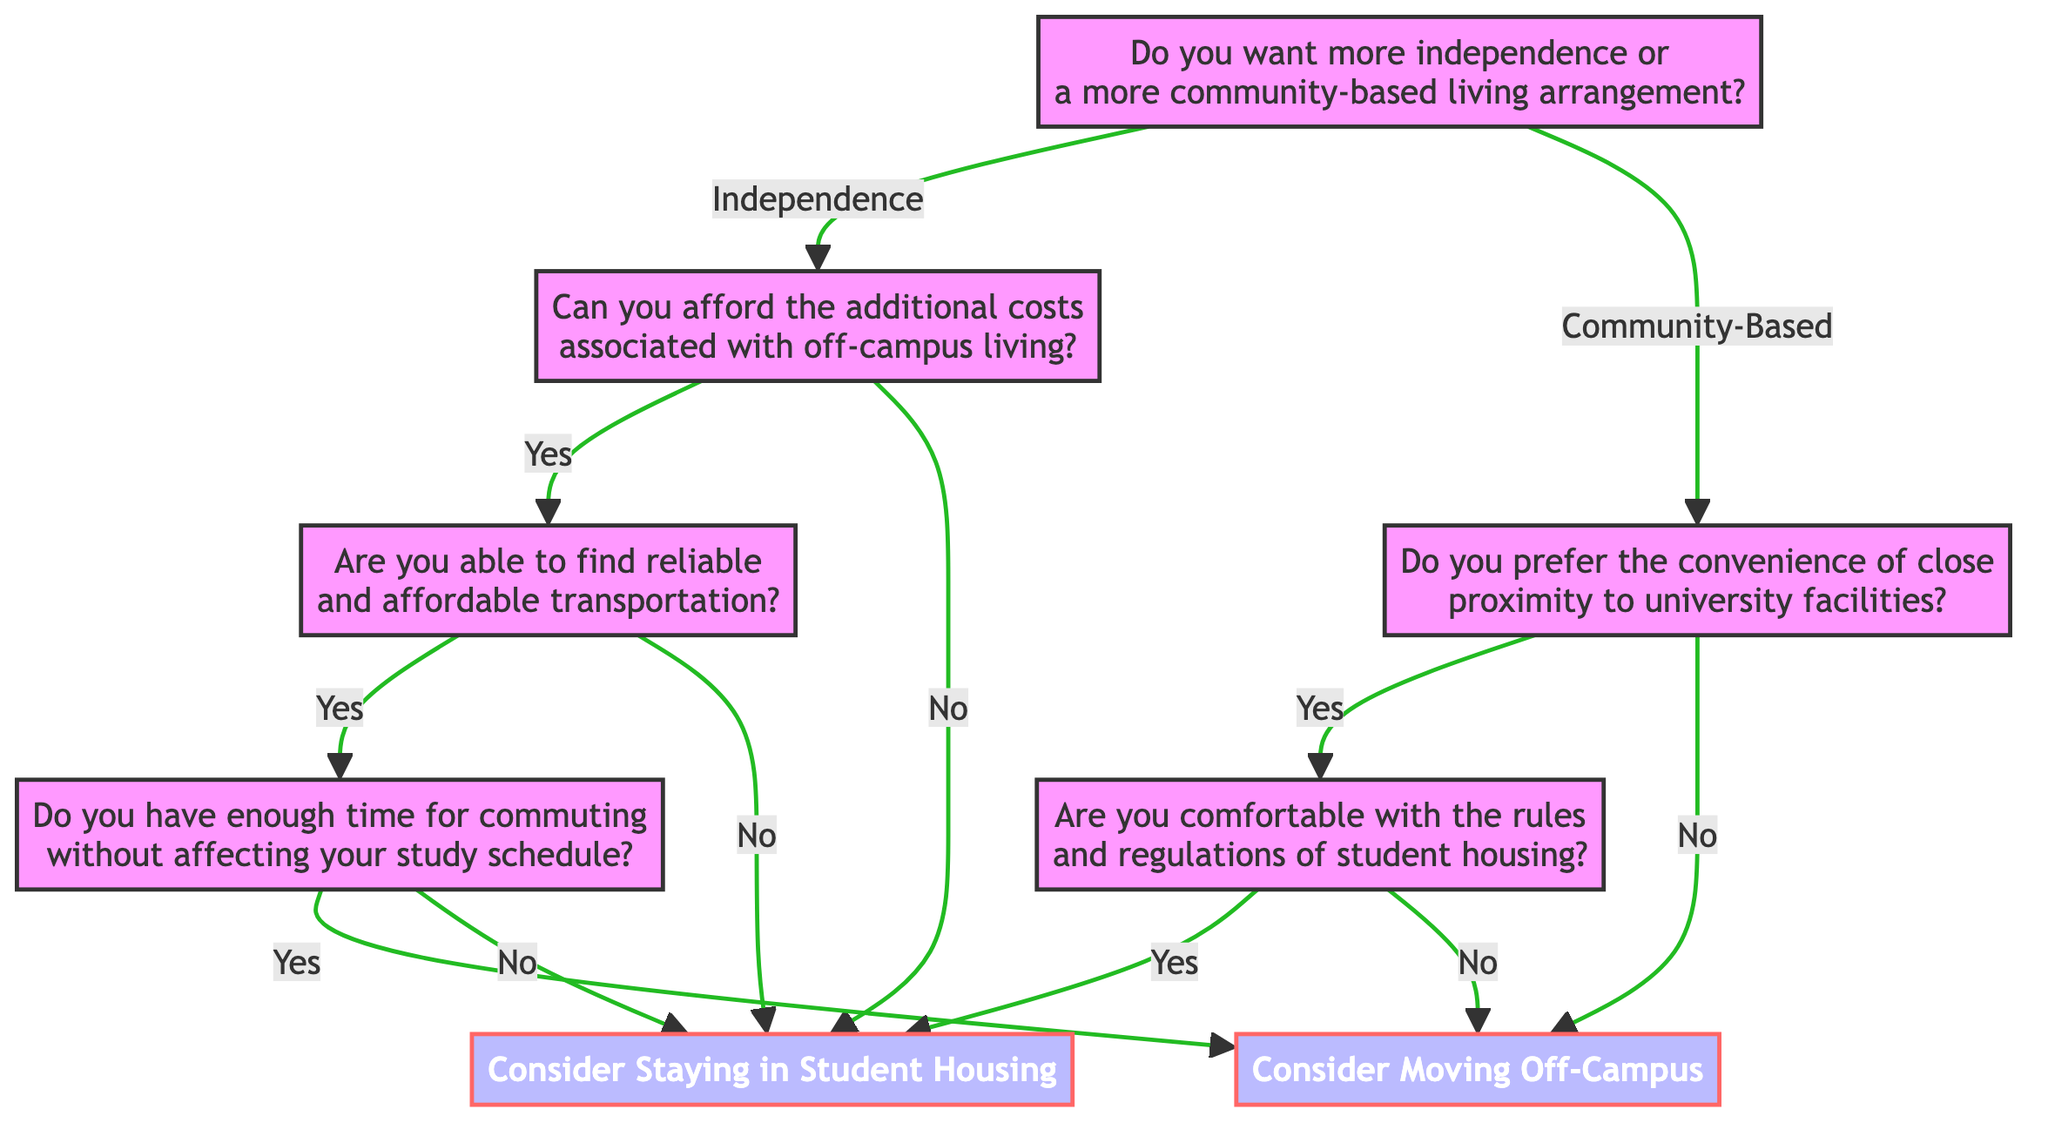What is the first question in the decision tree? The first question in the decision tree is located at the root node. It asks if the person wants more independence or a more community-based living arrangement.
Answer: Do you want more independence or a more community-based living arrangement? How many options are available after the first question? The first question splits into two distinct options: 'Independence' and 'Community-Based', making a total of two options.
Answer: 2 What does the decision lead to if the answer is 'No' to the question about affordability? If the answer is 'No' to the question about affordability, the decision is to "Consider Staying in Student Housing," which is an endpoint of that branch.
Answer: Consider Staying in Student Housing If someone prefers community-based living and answers 'No' to close proximity to university facilities, what is the next step? If someone prefers community-based living and answers 'No' to the question about proximity, they immediately proceed to the decision "Consider Moving Off-Campus," as it is an endpoint of that branch.
Answer: Consider Moving Off-Campus What happens if the answer is 'Yes' for both transportation and time for commuting? If both questions about transportation and commuting time are 'Yes', the final decision is to "Consider Moving Off-Campus," as this outcome follows a sequence of positive answers leading to that conclusion.
Answer: Consider Moving Off-Campus What is the outcome of answering 'Yes' to being comfortable with the rules in student housing? Answering 'Yes' to being comfortable with the rules leads directly to the decision to "Consider Staying in Student Housing," which is an endpoint of that branch.
Answer: Consider Staying in Student Housing How does the diagram address the option for transportation reliability? The question about reliable transportation splits into two paths: a 'Yes' leads to the next question about commuting time, and a 'No' leads directly to the decision to "Consider Staying in Student Housing." This illustrates the critical impact of transportation reliability on the final decision.
Answer: It splits into further questions or a direct decision What is the second question for those who want more independence in living arrangements? For those wanting more independence, the second question is about their ability to afford the additional costs associated with off-campus living.
Answer: Can you afford the additional costs associated with off-campus living? 